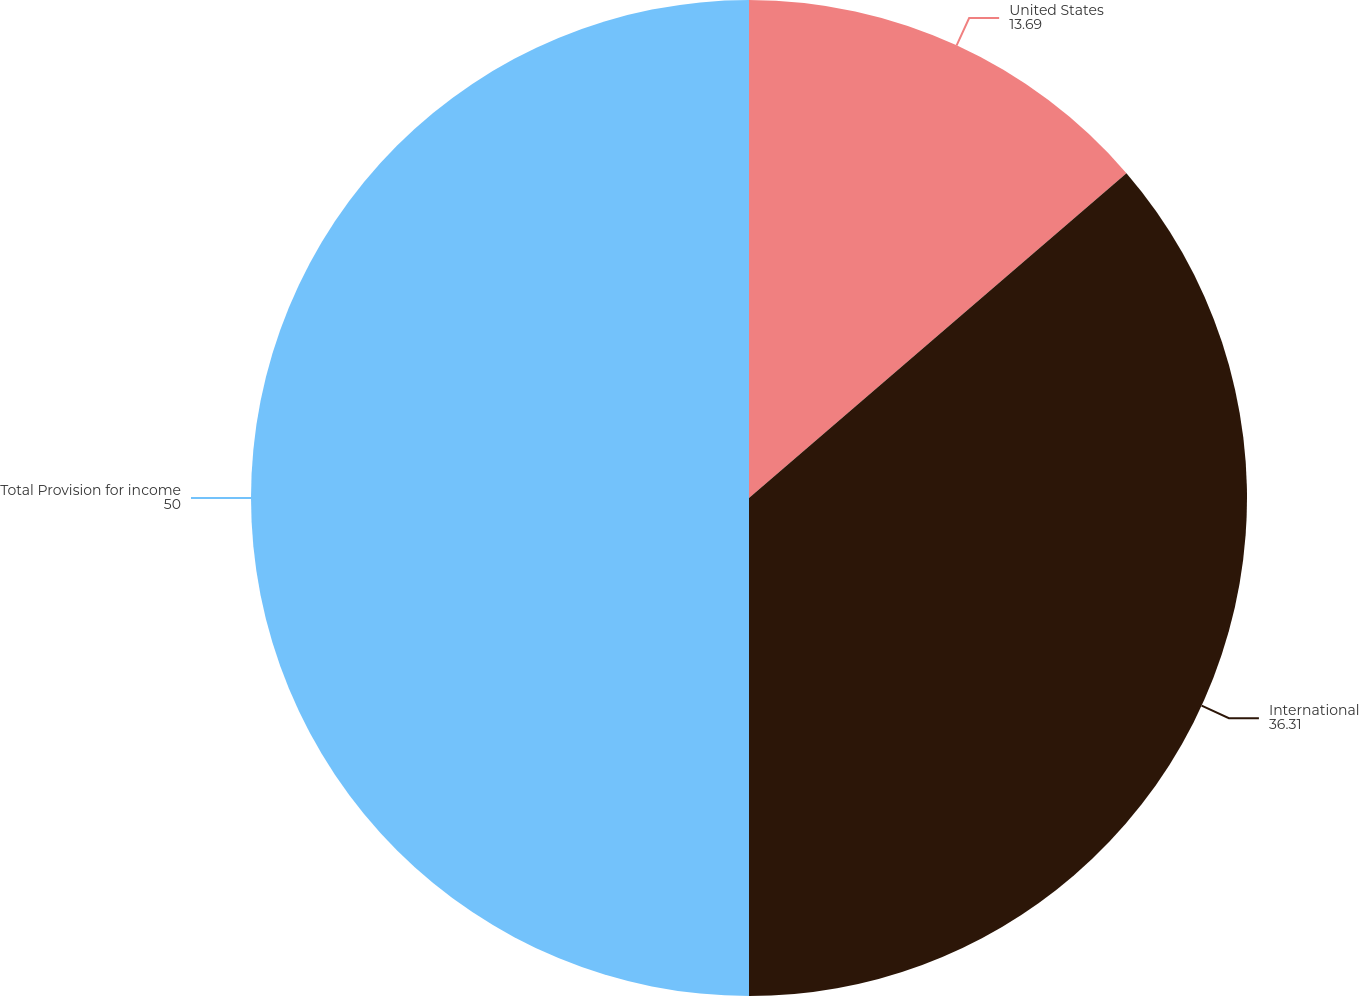<chart> <loc_0><loc_0><loc_500><loc_500><pie_chart><fcel>United States<fcel>International<fcel>Total Provision for income<nl><fcel>13.69%<fcel>36.31%<fcel>50.0%<nl></chart> 